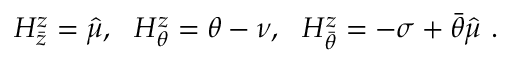<formula> <loc_0><loc_0><loc_500><loc_500>H _ { \bar { z } } ^ { z } = \hat { \mu } , H _ { \theta } ^ { z } = \theta - \nu , H _ { \bar { \theta } } ^ { z } = - \sigma + \bar { \theta } \hat { \mu } \ .</formula> 